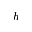Convert formula to latex. <formula><loc_0><loc_0><loc_500><loc_500>h</formula> 